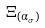Convert formula to latex. <formula><loc_0><loc_0><loc_500><loc_500>\Xi _ { ( \alpha _ { \sigma } ) }</formula> 